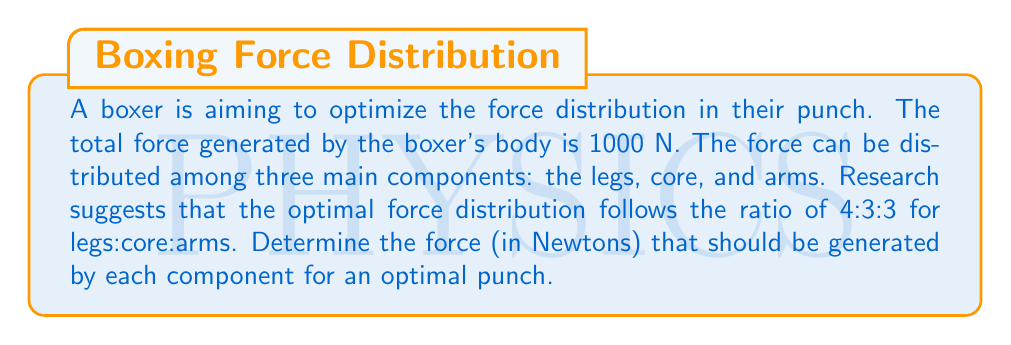Give your solution to this math problem. To solve this problem, we need to follow these steps:

1) Let's define our variables:
   $x$ = force generated by legs
   $y$ = force generated by core
   $z$ = force generated by arms

2) We know that the total force is 1000 N, so:

   $$x + y + z = 1000$$

3) The optimal ratio is 4:3:3, which means:

   $$x : y : z = 4 : 3 : 3$$

4) We can express $y$ and $z$ in terms of $x$:

   $$y = \frac{3}{4}x$$
   $$z = \frac{3}{4}x$$

5) Substituting these into our total force equation:

   $$x + \frac{3}{4}x + \frac{3}{4}x = 1000$$

6) Simplifying:

   $$x + \frac{6}{4}x = 1000$$
   $$\frac{10}{4}x = 1000$$
   $$x = 400$$

7) Now we can calculate $y$ and $z$:

   $$y = \frac{3}{4} * 400 = 300$$
   $$z = \frac{3}{4} * 400 = 300$$

8) Verify:

   $$400 + 300 + 300 = 1000$$

Therefore, the optimal force distribution is:
Legs: 400 N
Core: 300 N
Arms: 300 N
Answer: Legs: 400 N, Core: 300 N, Arms: 300 N 